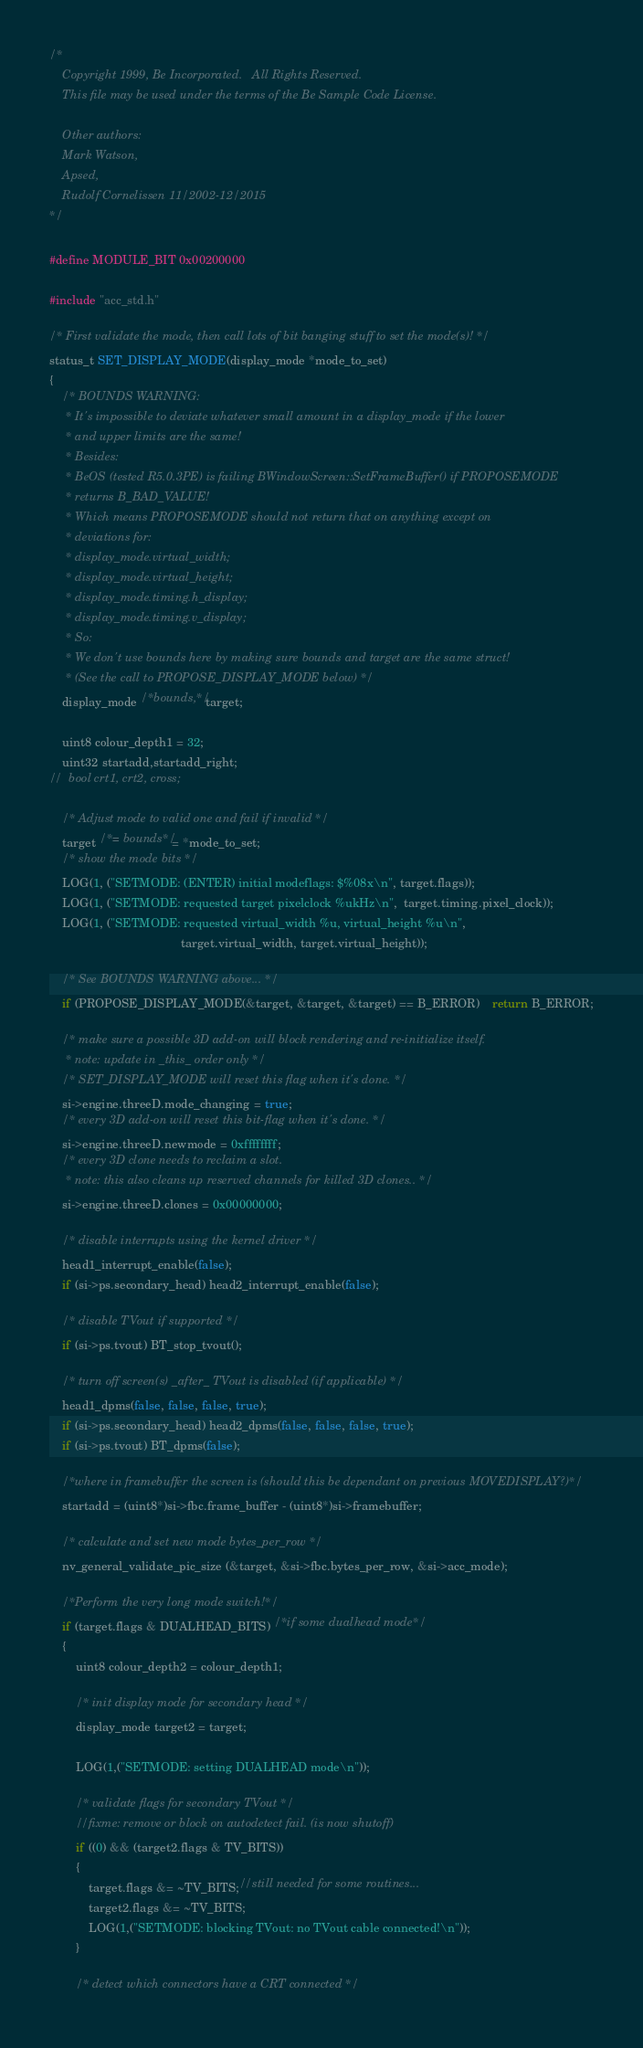<code> <loc_0><loc_0><loc_500><loc_500><_C_>
/*
	Copyright 1999, Be Incorporated.   All Rights Reserved.
	This file may be used under the terms of the Be Sample Code License.

	Other authors:
	Mark Watson,
	Apsed,
	Rudolf Cornelissen 11/2002-12/2015
*/

#define MODULE_BIT 0x00200000

#include "acc_std.h"

/* First validate the mode, then call lots of bit banging stuff to set the mode(s)! */
status_t SET_DISPLAY_MODE(display_mode *mode_to_set) 
{
	/* BOUNDS WARNING:
	 * It's impossible to deviate whatever small amount in a display_mode if the lower
	 * and upper limits are the same!
	 * Besides:
	 * BeOS (tested R5.0.3PE) is failing BWindowScreen::SetFrameBuffer() if PROPOSEMODE
	 * returns B_BAD_VALUE!
	 * Which means PROPOSEMODE should not return that on anything except on
	 * deviations for:
	 * display_mode.virtual_width;
	 * display_mode.virtual_height;
	 * display_mode.timing.h_display;
	 * display_mode.timing.v_display;
	 * So:
	 * We don't use bounds here by making sure bounds and target are the same struct!
	 * (See the call to PROPOSE_DISPLAY_MODE below) */
	display_mode /*bounds,*/ target;

	uint8 colour_depth1 = 32;
	uint32 startadd,startadd_right;
//	bool crt1, crt2, cross;

	/* Adjust mode to valid one and fail if invalid */
	target /*= bounds*/ = *mode_to_set;
	/* show the mode bits */
	LOG(1, ("SETMODE: (ENTER) initial modeflags: $%08x\n", target.flags));
	LOG(1, ("SETMODE: requested target pixelclock %ukHz\n",  target.timing.pixel_clock));
	LOG(1, ("SETMODE: requested virtual_width %u, virtual_height %u\n",
										target.virtual_width, target.virtual_height));

	/* See BOUNDS WARNING above... */
	if (PROPOSE_DISPLAY_MODE(&target, &target, &target) == B_ERROR)	return B_ERROR;

	/* make sure a possible 3D add-on will block rendering and re-initialize itself.
	 * note: update in _this_ order only */
	/* SET_DISPLAY_MODE will reset this flag when it's done. */
	si->engine.threeD.mode_changing = true;
	/* every 3D add-on will reset this bit-flag when it's done. */
	si->engine.threeD.newmode = 0xffffffff;
	/* every 3D clone needs to reclaim a slot.
	 * note: this also cleans up reserved channels for killed 3D clones.. */
	si->engine.threeD.clones = 0x00000000;

	/* disable interrupts using the kernel driver */
	head1_interrupt_enable(false);
	if (si->ps.secondary_head) head2_interrupt_enable(false);

	/* disable TVout if supported */
	if (si->ps.tvout) BT_stop_tvout();

	/* turn off screen(s) _after_ TVout is disabled (if applicable) */
	head1_dpms(false, false, false, true);
	if (si->ps.secondary_head) head2_dpms(false, false, false, true);
	if (si->ps.tvout) BT_dpms(false);

	/*where in framebuffer the screen is (should this be dependant on previous MOVEDISPLAY?)*/
	startadd = (uint8*)si->fbc.frame_buffer - (uint8*)si->framebuffer;

	/* calculate and set new mode bytes_per_row */
	nv_general_validate_pic_size (&target, &si->fbc.bytes_per_row, &si->acc_mode);

	/*Perform the very long mode switch!*/
	if (target.flags & DUALHEAD_BITS) /*if some dualhead mode*/
	{
		uint8 colour_depth2 = colour_depth1;

		/* init display mode for secondary head */		
		display_mode target2 = target;

		LOG(1,("SETMODE: setting DUALHEAD mode\n"));

		/* validate flags for secondary TVout */
		//fixme: remove or block on autodetect fail. (is now shutoff)
		if ((0) && (target2.flags & TV_BITS))
		{
			target.flags &= ~TV_BITS;//still needed for some routines...
			target2.flags &= ~TV_BITS;
			LOG(1,("SETMODE: blocking TVout: no TVout cable connected!\n"));
		}

		/* detect which connectors have a CRT connected */</code> 